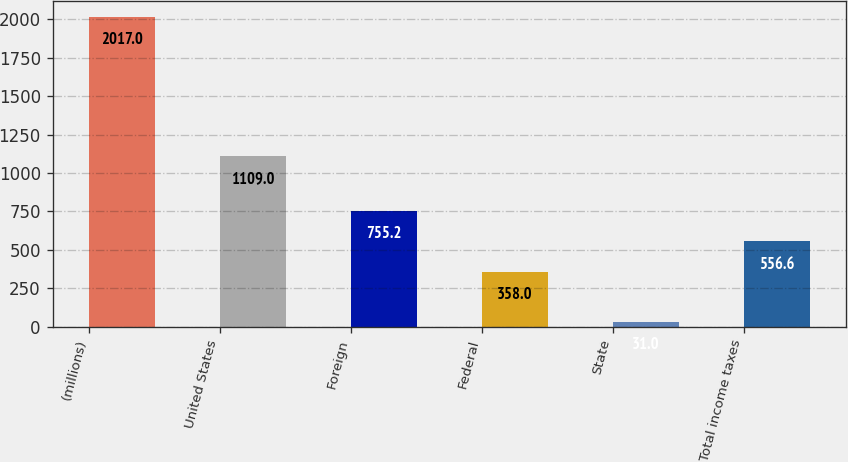Convert chart. <chart><loc_0><loc_0><loc_500><loc_500><bar_chart><fcel>(millions)<fcel>United States<fcel>Foreign<fcel>Federal<fcel>State<fcel>Total income taxes<nl><fcel>2017<fcel>1109<fcel>755.2<fcel>358<fcel>31<fcel>556.6<nl></chart> 